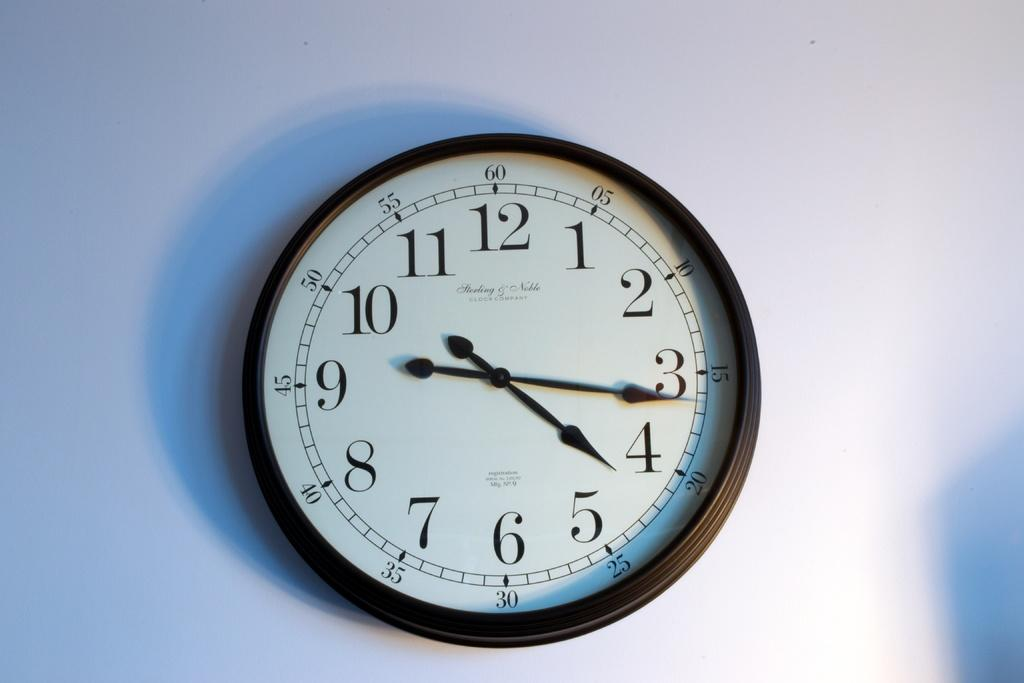<image>
Write a terse but informative summary of the picture. A clock manufactured by Sterling and Noble hanging on a wall. 